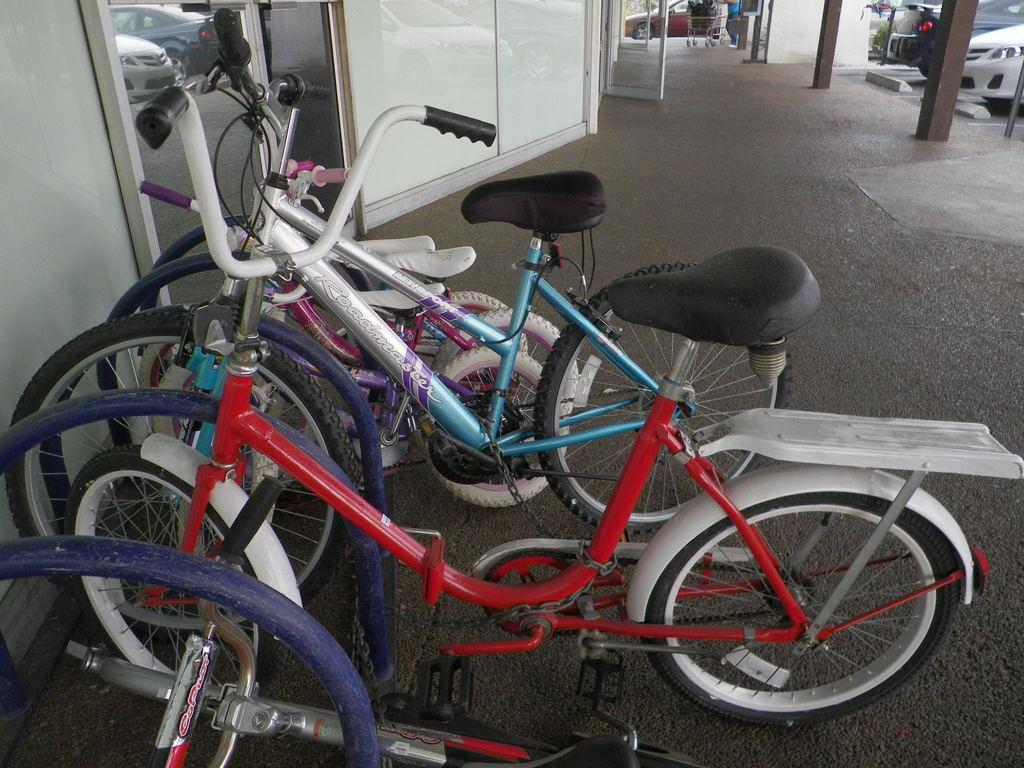Can you describe this image briefly? In this image we can see cycles. Near to the cycle there is a mirror. On the mirror we can see cars. At the top we can see a door. Also there are poles. Also we can see a car. 